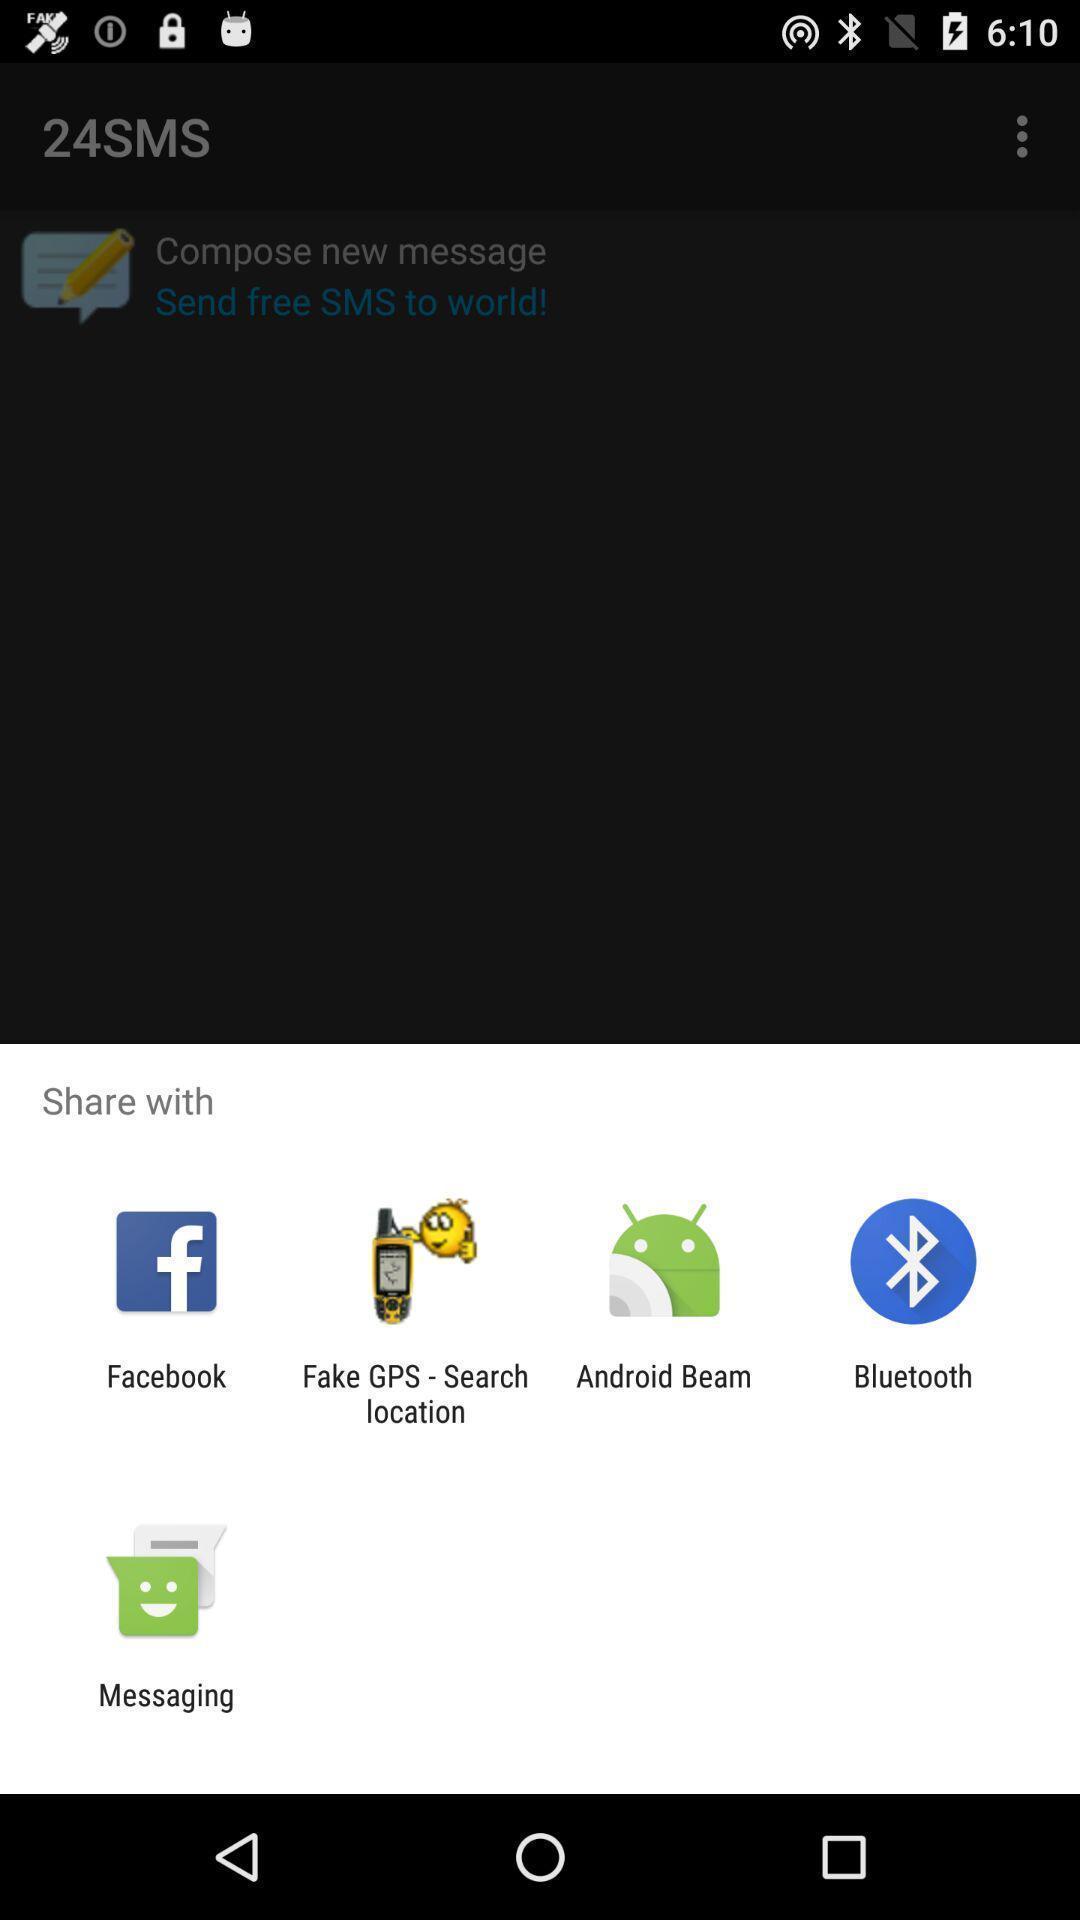Summarize the main components in this picture. Share information with different apps. 